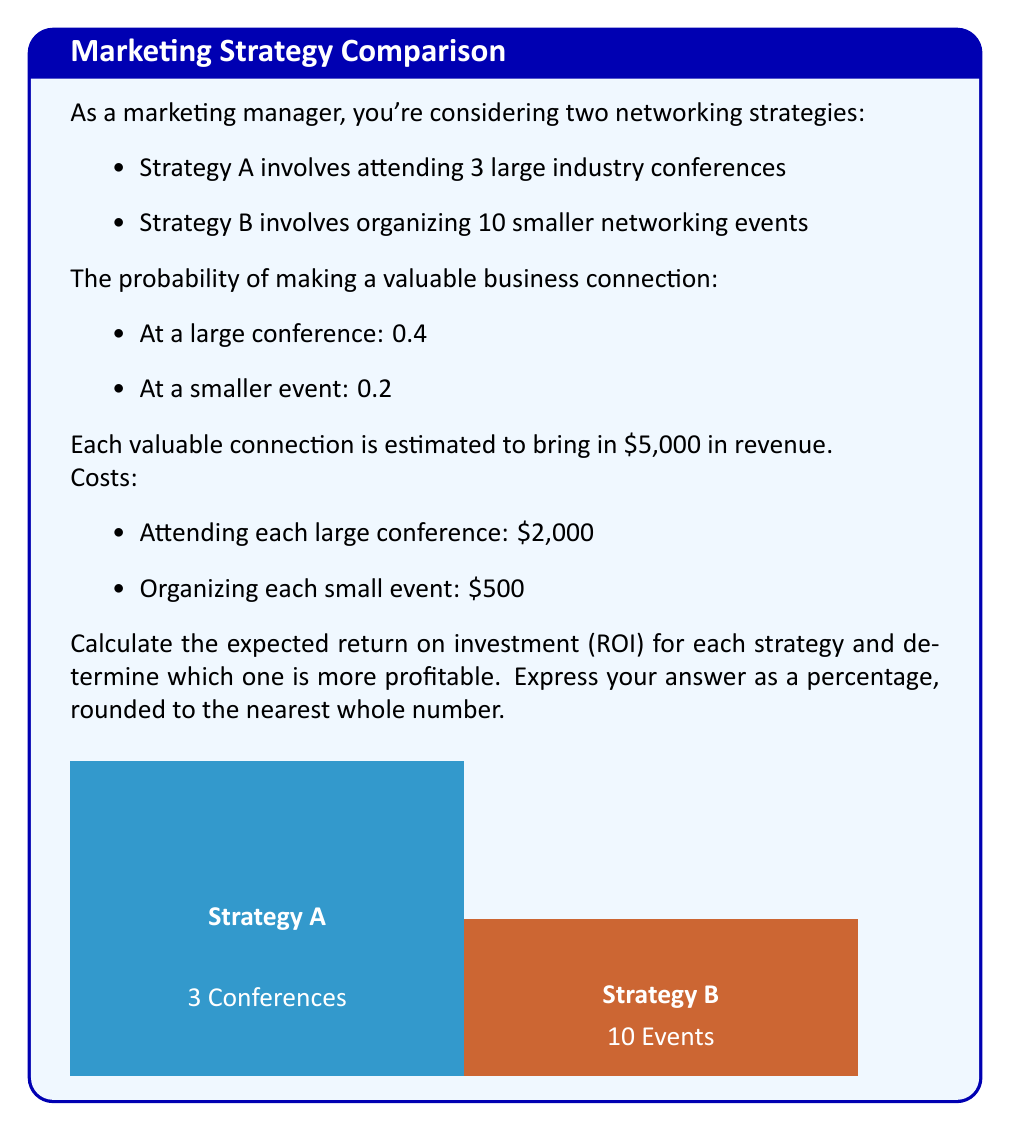Could you help me with this problem? Let's break this down step-by-step:

1) First, let's calculate the expected revenue for each strategy:

   Strategy A (Conferences):
   - Number of conferences: 3
   - Probability of connection per conference: 0.4
   - Expected number of connections: $3 * 0.4 = 1.2$
   - Expected revenue: $1.2 * $5,000 = $6,000$

   Strategy B (Small Events):
   - Number of events: 10
   - Probability of connection per event: 0.2
   - Expected number of connections: $10 * 0.2 = 2$
   - Expected revenue: $2 * $5,000 = $10,000$

2) Now, let's calculate the costs for each strategy:

   Strategy A: $3 * $2,000 = $6,000$
   Strategy B: $10 * $500 = $5,000$

3) The profit for each strategy is revenue minus cost:

   Strategy A: $6,000 - $6,000 = $0$
   Strategy B: $10,000 - $5,000 = $5,000$

4) The ROI is calculated as: $ROI = \frac{\text{Profit}}{\text{Cost}} * 100\%$

   Strategy A: $ROI_A = \frac{0}{6000} * 100\% = 0\%$
   
   Strategy B: $ROI_B = \frac{5000}{5000} * 100\% = 100\%$

5) Rounding to the nearest whole number:
   Strategy A: 0%
   Strategy B: 100%

Therefore, Strategy B (organizing smaller events) is more profitable with an expected ROI of 100%, compared to Strategy A's 0% ROI.
Answer: Strategy B: 100% 